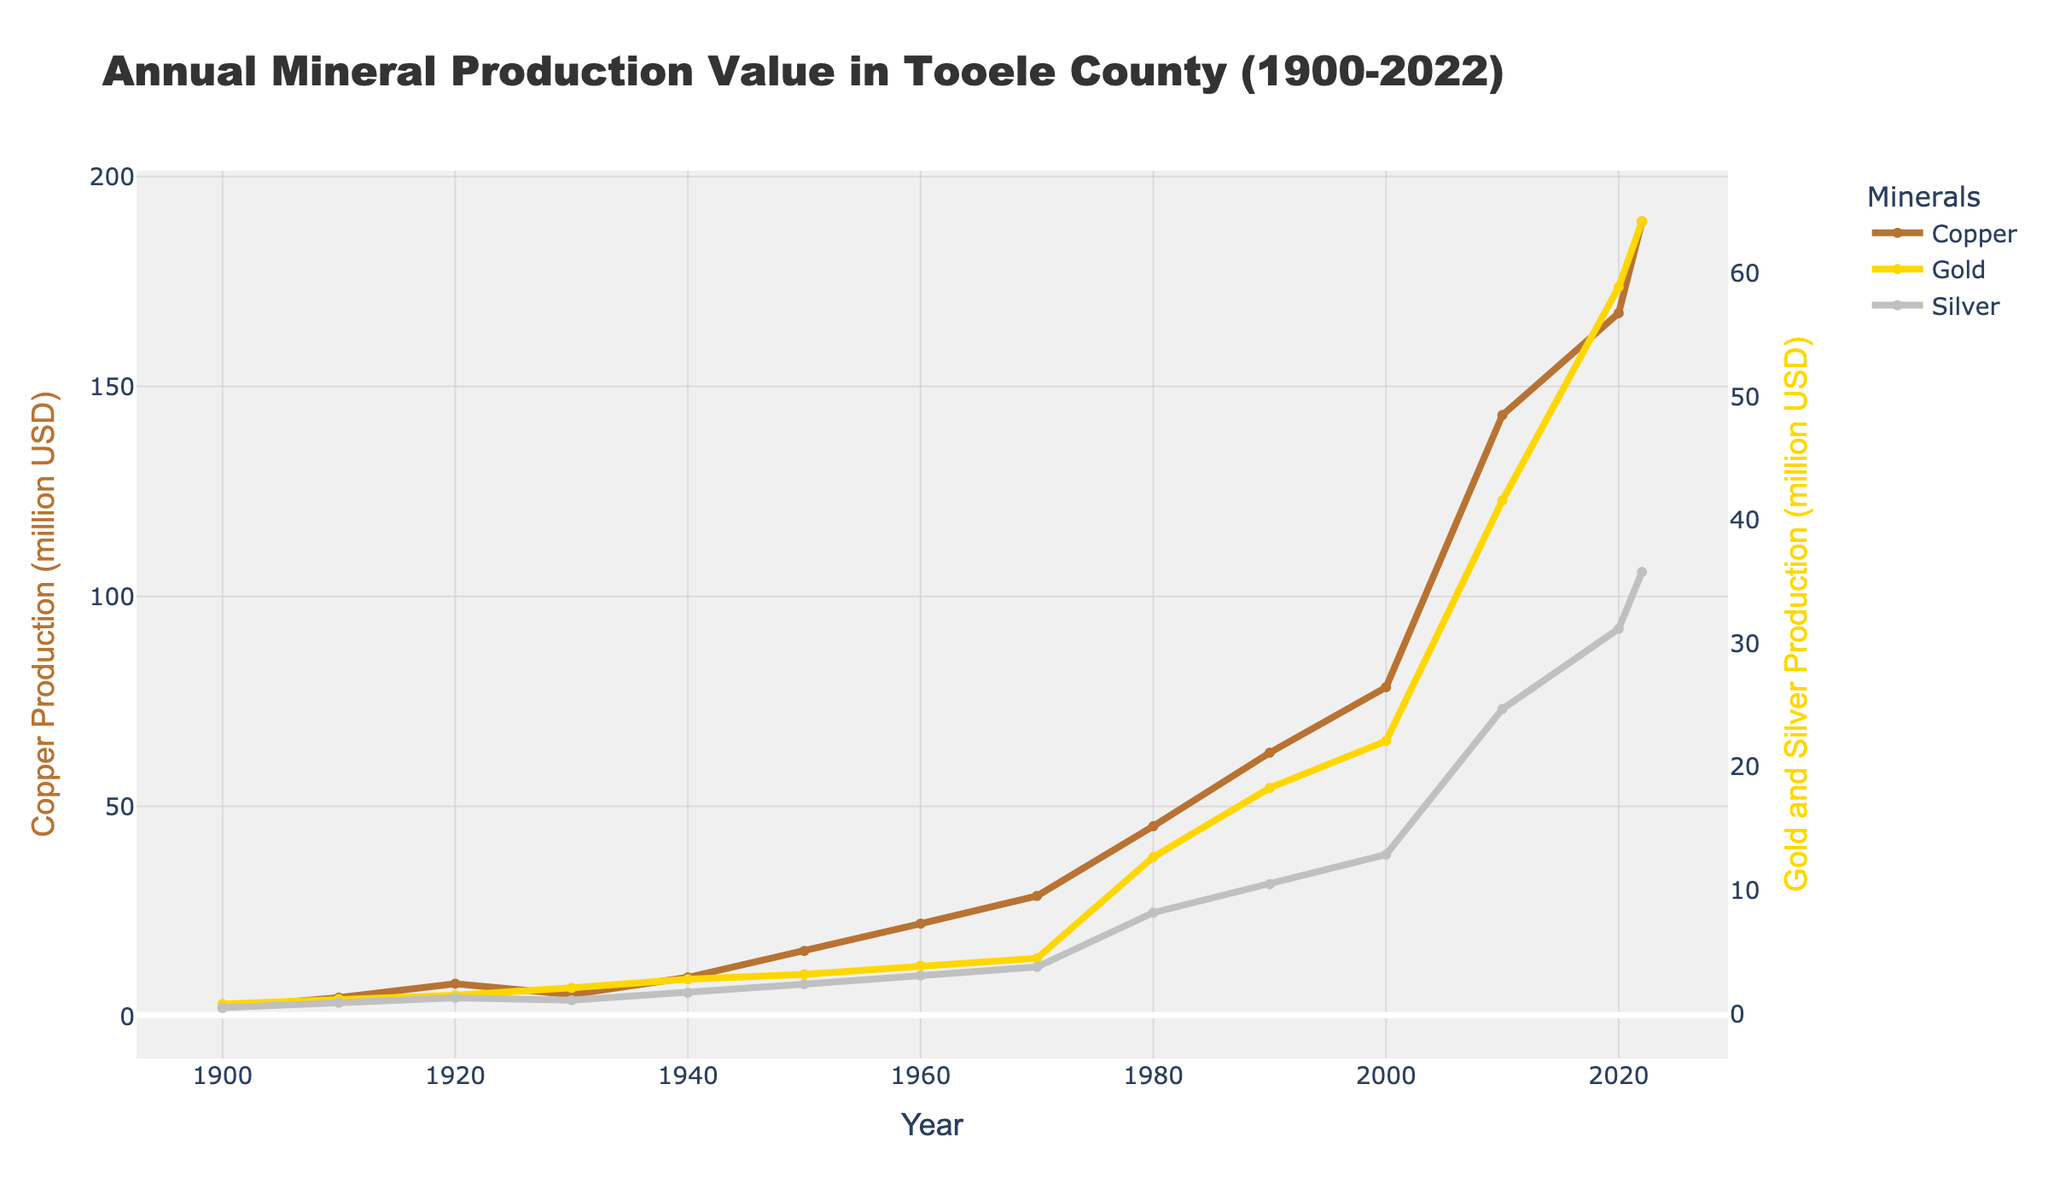What year did copper production surpass $100 million? To determine this, locate the point where the copper line (brown) crosses the $100 million mark on the y-axis. This occurs around the year 2010.
Answer: 2010 How much more was the gold production value compared to the silver production value in 2022? Look at the y-values for both gold (yellow) and silver (gray) in 2022: gold is $64.2 million, and silver is $35.8 million. Subtract silver's value from gold's value: 64.2 - 35.8 = 28.4.
Answer: $28.4 million What is the average value of copper production from 1900 to 2022? Sum the copper production values provided for each year and divide by the number of years: (2.1+4.5+7.8+5.2+9.3+15.6+22.1+28.7+45.3+62.8+78.4+143.2+167.5+189.3)/14 = 57.29.
Answer: $57.29 million Between which two consecutive decades did silver production have the highest increase? Observe the silver line (gray) and compare the vertical distances between data points from decade to decade. The steepest upward slope occurs between 1970 and 1980, increasing from $3.8 million to $8.2 million.
Answer: 1970-1980 Which mineral had the largest percentage increase in production from 2010 to 2022? Calculate the percentage increase for each mineral between 2010 and 2022. Copper: ((189.3 - 143.2) / 143.2) * 100% = 32.22%. Gold: ((64.2 - 41.6) / 41.6) * 100% = 54.33%. Silver: ((35.8 - 24.7) / 24.7) * 100% = 44.94%. Gold had the largest percentage increase.
Answer: Gold Which mineral had the smallest production value in 1940? Compare the y-values for copper (brown), gold (yellow), and silver (gray) in 1940: copper is $9.3 million, gold is $2.8 million, and silver is $1.7 million. Thus, silver had the smallest production value.
Answer: Silver How did the production of copper change from 1920 to 1930? Look at the copper line (brown) between 1920 and 1930. The production value decreased from $7.8 million to $5.2 million. Subtract the values: 7.8 - 5.2 = 2.6. Copper production decreased by $2.6 million.
Answer: Decreased by $2.6 million What was the combined production value of gold and silver in 2000? Add the y-values for gold (yellow) and silver (gray) in 2000: 22.1 (gold) + 12.9 (silver) = 35.0.
Answer: $35.0 million 